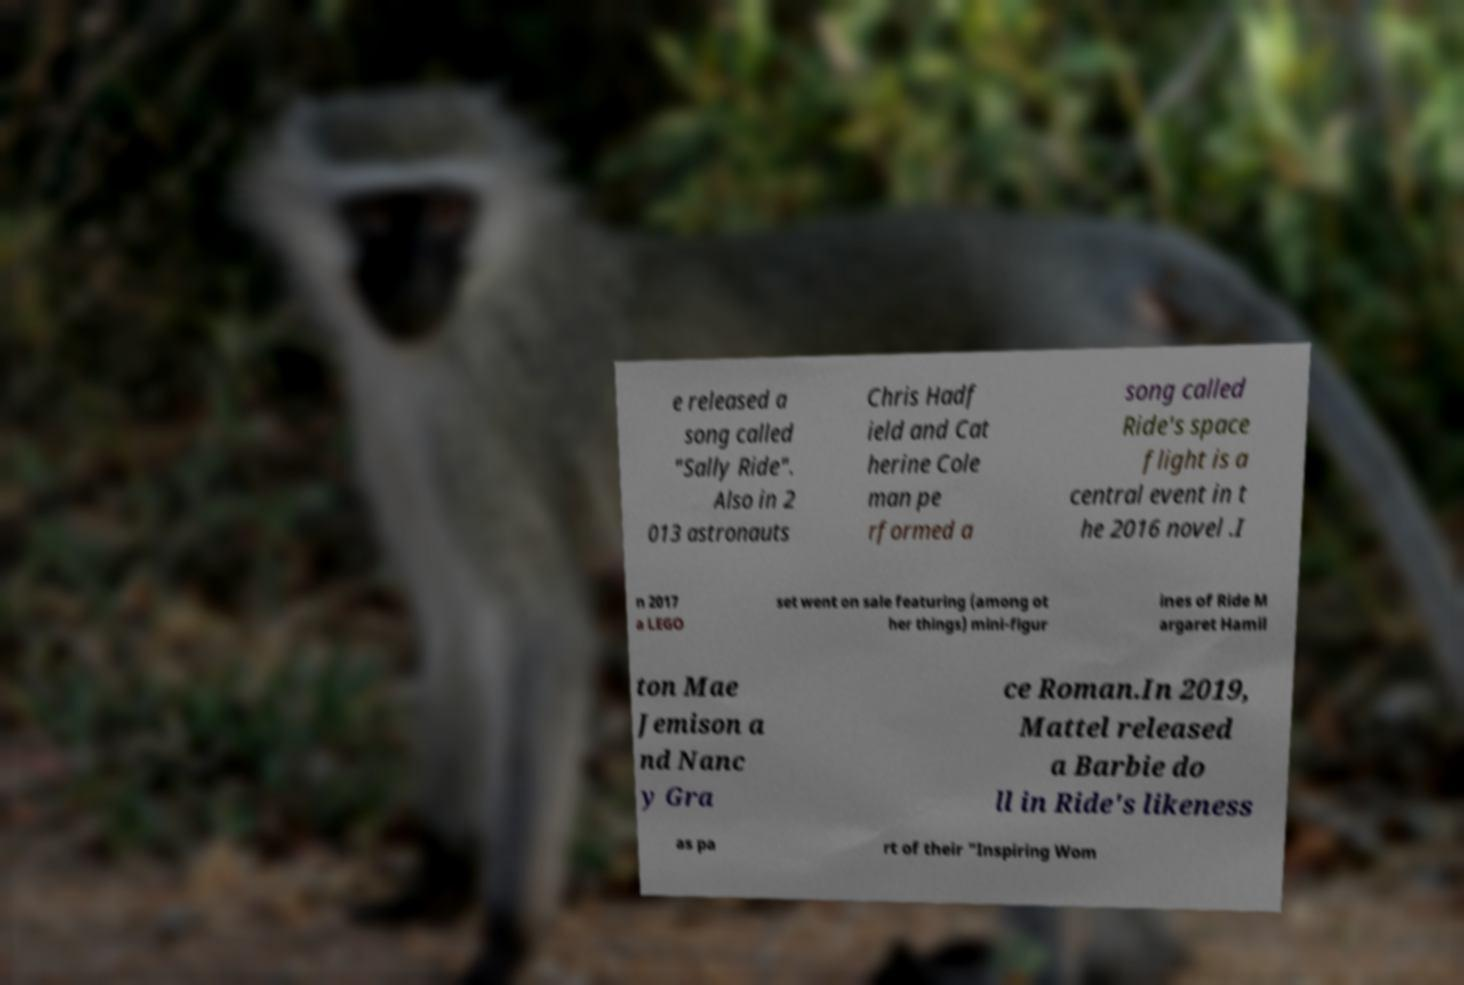Can you read and provide the text displayed in the image?This photo seems to have some interesting text. Can you extract and type it out for me? e released a song called "Sally Ride". Also in 2 013 astronauts Chris Hadf ield and Cat herine Cole man pe rformed a song called Ride's space flight is a central event in t he 2016 novel .I n 2017 a LEGO set went on sale featuring (among ot her things) mini-figur ines of Ride M argaret Hamil ton Mae Jemison a nd Nanc y Gra ce Roman.In 2019, Mattel released a Barbie do ll in Ride's likeness as pa rt of their "Inspiring Wom 